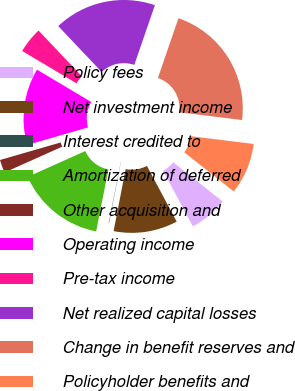Convert chart to OTSL. <chart><loc_0><loc_0><loc_500><loc_500><pie_chart><fcel>Policy fees<fcel>Net investment income<fcel>Interest credited to<fcel>Amortization of deferred<fcel>Other acquisition and<fcel>Operating income<fcel>Pre-tax income<fcel>Net realized capital losses<fcel>Change in benefit reserves and<fcel>Policyholder benefits and<nl><fcel>6.54%<fcel>10.86%<fcel>0.06%<fcel>15.19%<fcel>2.22%<fcel>13.03%<fcel>4.38%<fcel>17.35%<fcel>21.67%<fcel>8.7%<nl></chart> 